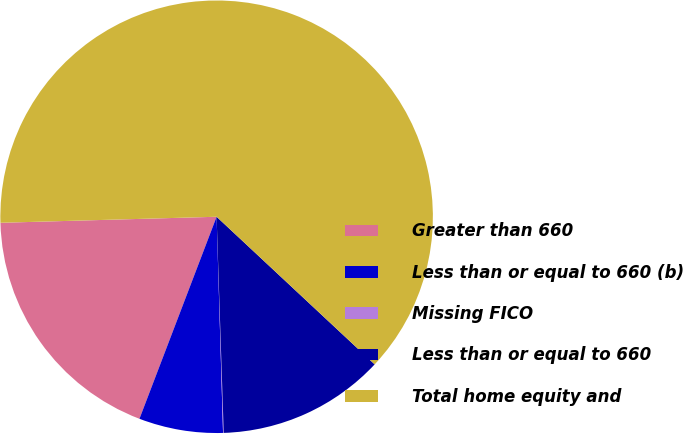Convert chart. <chart><loc_0><loc_0><loc_500><loc_500><pie_chart><fcel>Greater than 660<fcel>Less than or equal to 660 (b)<fcel>Missing FICO<fcel>Less than or equal to 660<fcel>Total home equity and<nl><fcel>18.75%<fcel>6.28%<fcel>0.05%<fcel>12.52%<fcel>62.4%<nl></chart> 